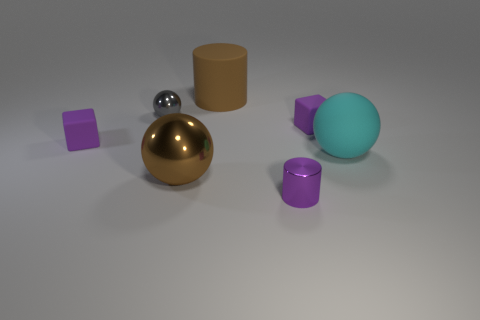Add 2 big cyan spheres. How many objects exist? 9 Subtract all cubes. How many objects are left? 5 Add 2 purple matte blocks. How many purple matte blocks are left? 4 Add 6 big cylinders. How many big cylinders exist? 7 Subtract 0 cyan blocks. How many objects are left? 7 Subtract all yellow cylinders. Subtract all balls. How many objects are left? 4 